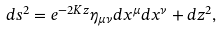<formula> <loc_0><loc_0><loc_500><loc_500>d s ^ { 2 } = e ^ { - 2 K z } \eta _ { \mu \nu } d x ^ { \mu } d x ^ { \nu } + d z ^ { 2 } ,</formula> 